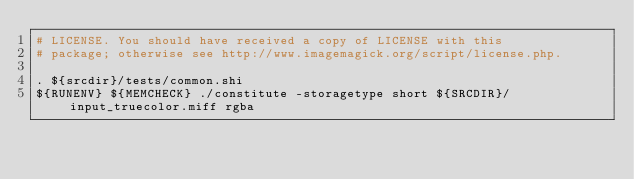<code> <loc_0><loc_0><loc_500><loc_500><_Bash_># LICENSE. You should have received a copy of LICENSE with this
# package; otherwise see http://www.imagemagick.org/script/license.php.

. ${srcdir}/tests/common.shi
${RUNENV} ${MEMCHECK} ./constitute -storagetype short ${SRCDIR}/input_truecolor.miff rgba
</code> 